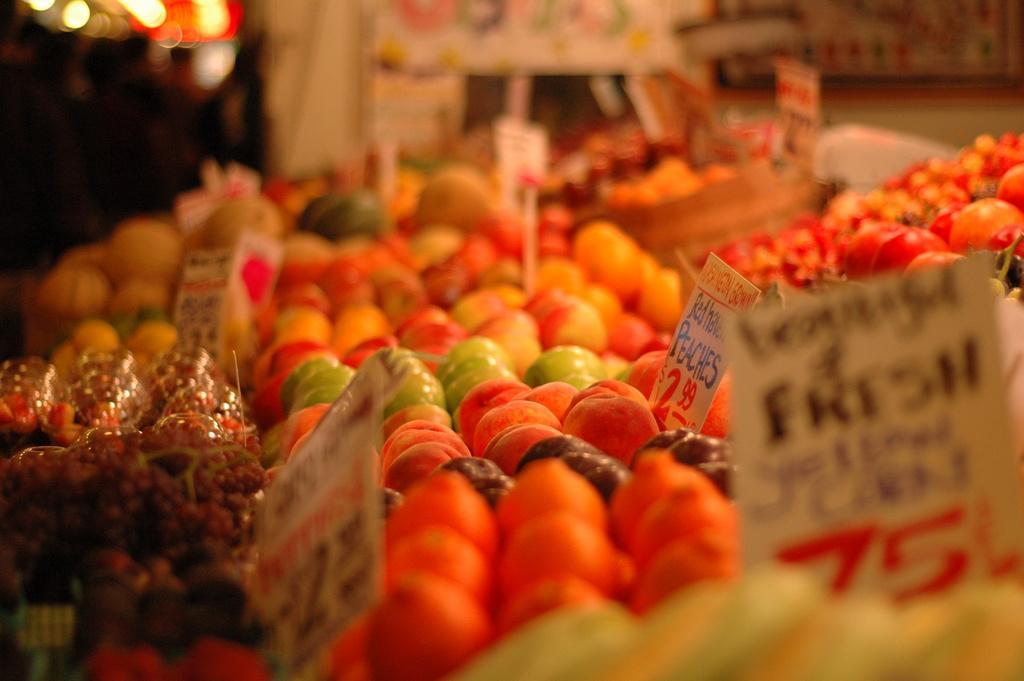How would you summarize this image in a sentence or two? In this image there are many fruits. In between there are boards with text. The background is blurry. 